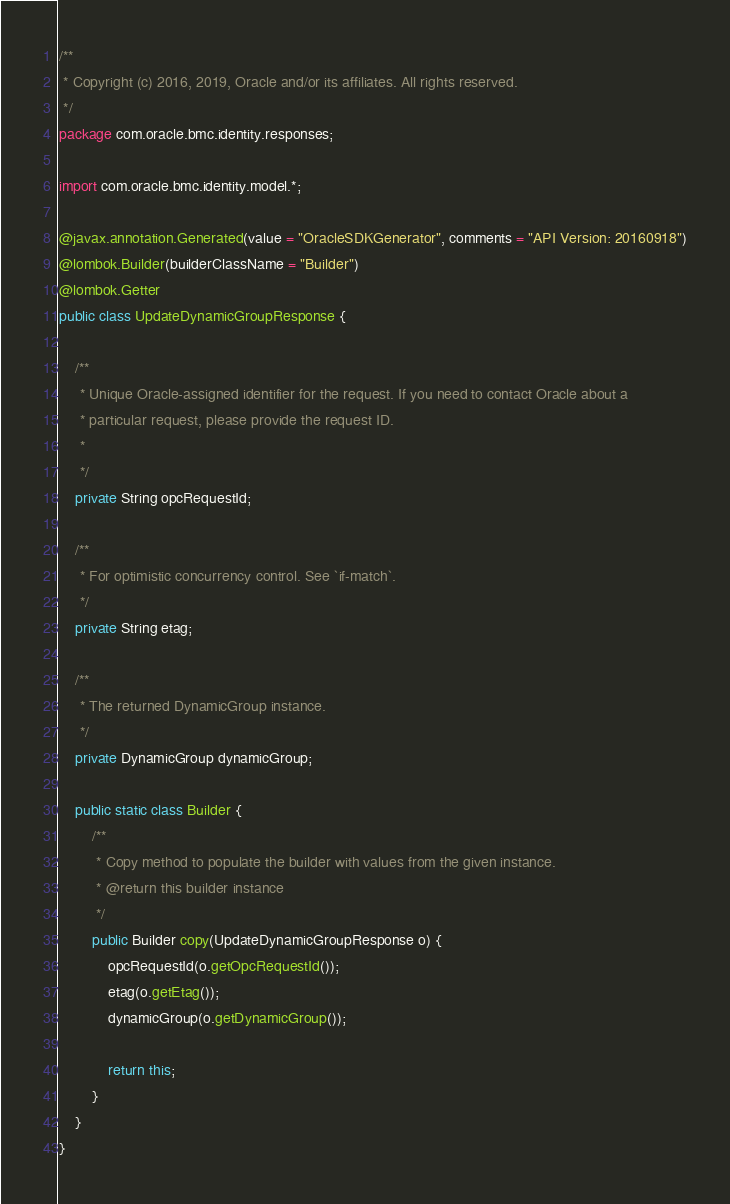<code> <loc_0><loc_0><loc_500><loc_500><_Java_>/**
 * Copyright (c) 2016, 2019, Oracle and/or its affiliates. All rights reserved.
 */
package com.oracle.bmc.identity.responses;

import com.oracle.bmc.identity.model.*;

@javax.annotation.Generated(value = "OracleSDKGenerator", comments = "API Version: 20160918")
@lombok.Builder(builderClassName = "Builder")
@lombok.Getter
public class UpdateDynamicGroupResponse {

    /**
     * Unique Oracle-assigned identifier for the request. If you need to contact Oracle about a
     * particular request, please provide the request ID.
     *
     */
    private String opcRequestId;

    /**
     * For optimistic concurrency control. See `if-match`.
     */
    private String etag;

    /**
     * The returned DynamicGroup instance.
     */
    private DynamicGroup dynamicGroup;

    public static class Builder {
        /**
         * Copy method to populate the builder with values from the given instance.
         * @return this builder instance
         */
        public Builder copy(UpdateDynamicGroupResponse o) {
            opcRequestId(o.getOpcRequestId());
            etag(o.getEtag());
            dynamicGroup(o.getDynamicGroup());

            return this;
        }
    }
}
</code> 